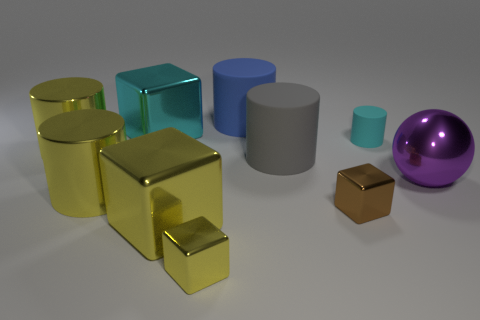Subtract 2 cylinders. How many cylinders are left? 3 Subtract all blue cylinders. How many cylinders are left? 4 Subtract all big blue matte cylinders. How many cylinders are left? 4 Subtract all purple cylinders. Subtract all purple blocks. How many cylinders are left? 5 Subtract all cubes. How many objects are left? 6 Add 3 purple metallic spheres. How many purple metallic spheres are left? 4 Add 3 brown blocks. How many brown blocks exist? 4 Subtract 0 purple cylinders. How many objects are left? 10 Subtract all big gray things. Subtract all gray matte cylinders. How many objects are left? 8 